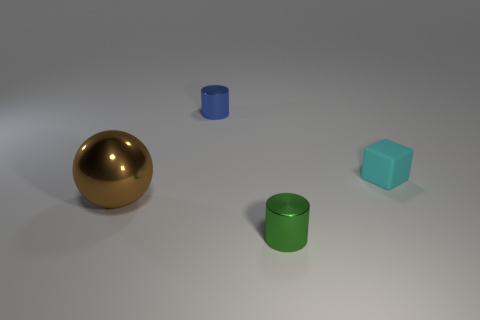Is there anything else that has the same size as the brown metal object?
Ensure brevity in your answer.  No. Is there anything else that is made of the same material as the cyan thing?
Keep it short and to the point. No. Are there more yellow objects than cyan matte things?
Provide a succinct answer. No. What shape is the thing that is to the right of the tiny shiny cylinder in front of the shiny object behind the sphere?
Your answer should be compact. Cube. Does the cylinder behind the brown ball have the same material as the cylinder in front of the shiny ball?
Provide a short and direct response. Yes. What shape is the green thing that is made of the same material as the ball?
Your answer should be very brief. Cylinder. Is there anything else that is the same color as the tiny matte object?
Your answer should be very brief. No. What number of cylinders are there?
Your answer should be compact. 2. There is a small block that is behind the shiny cylinder that is in front of the cyan matte cube; what is its material?
Make the answer very short. Rubber. The metal object that is to the right of the tiny shiny cylinder that is behind the metallic thing that is in front of the large brown thing is what color?
Your answer should be very brief. Green. 